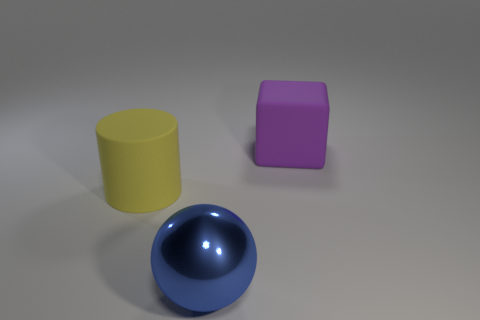Is there any other thing that is the same material as the sphere?
Offer a terse response. No. How many big objects are to the left of the large purple matte thing and behind the large metal sphere?
Your response must be concise. 1. What material is the big purple cube?
Keep it short and to the point. Rubber. Is there anything else that has the same color as the large metallic sphere?
Your answer should be very brief. No. Does the large cylinder have the same material as the block?
Your answer should be very brief. Yes. There is a big matte thing that is behind the matte thing that is in front of the big rubber cube; what number of big yellow rubber objects are to the left of it?
Provide a short and direct response. 1. How many rubber spheres are there?
Keep it short and to the point. 0. Are there fewer large spheres right of the big ball than purple matte cubes that are behind the rubber cylinder?
Keep it short and to the point. Yes. Are there fewer big blue things that are on the right side of the big blue ball than purple matte spheres?
Ensure brevity in your answer.  No. What is the material of the ball that is on the right side of the rubber thing that is on the left side of the big rubber object to the right of the large metal object?
Offer a very short reply. Metal. 